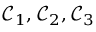Convert formula to latex. <formula><loc_0><loc_0><loc_500><loc_500>\mathcal { C } _ { 1 } , \mathcal { C } _ { 2 } , \mathcal { C } _ { 3 }</formula> 